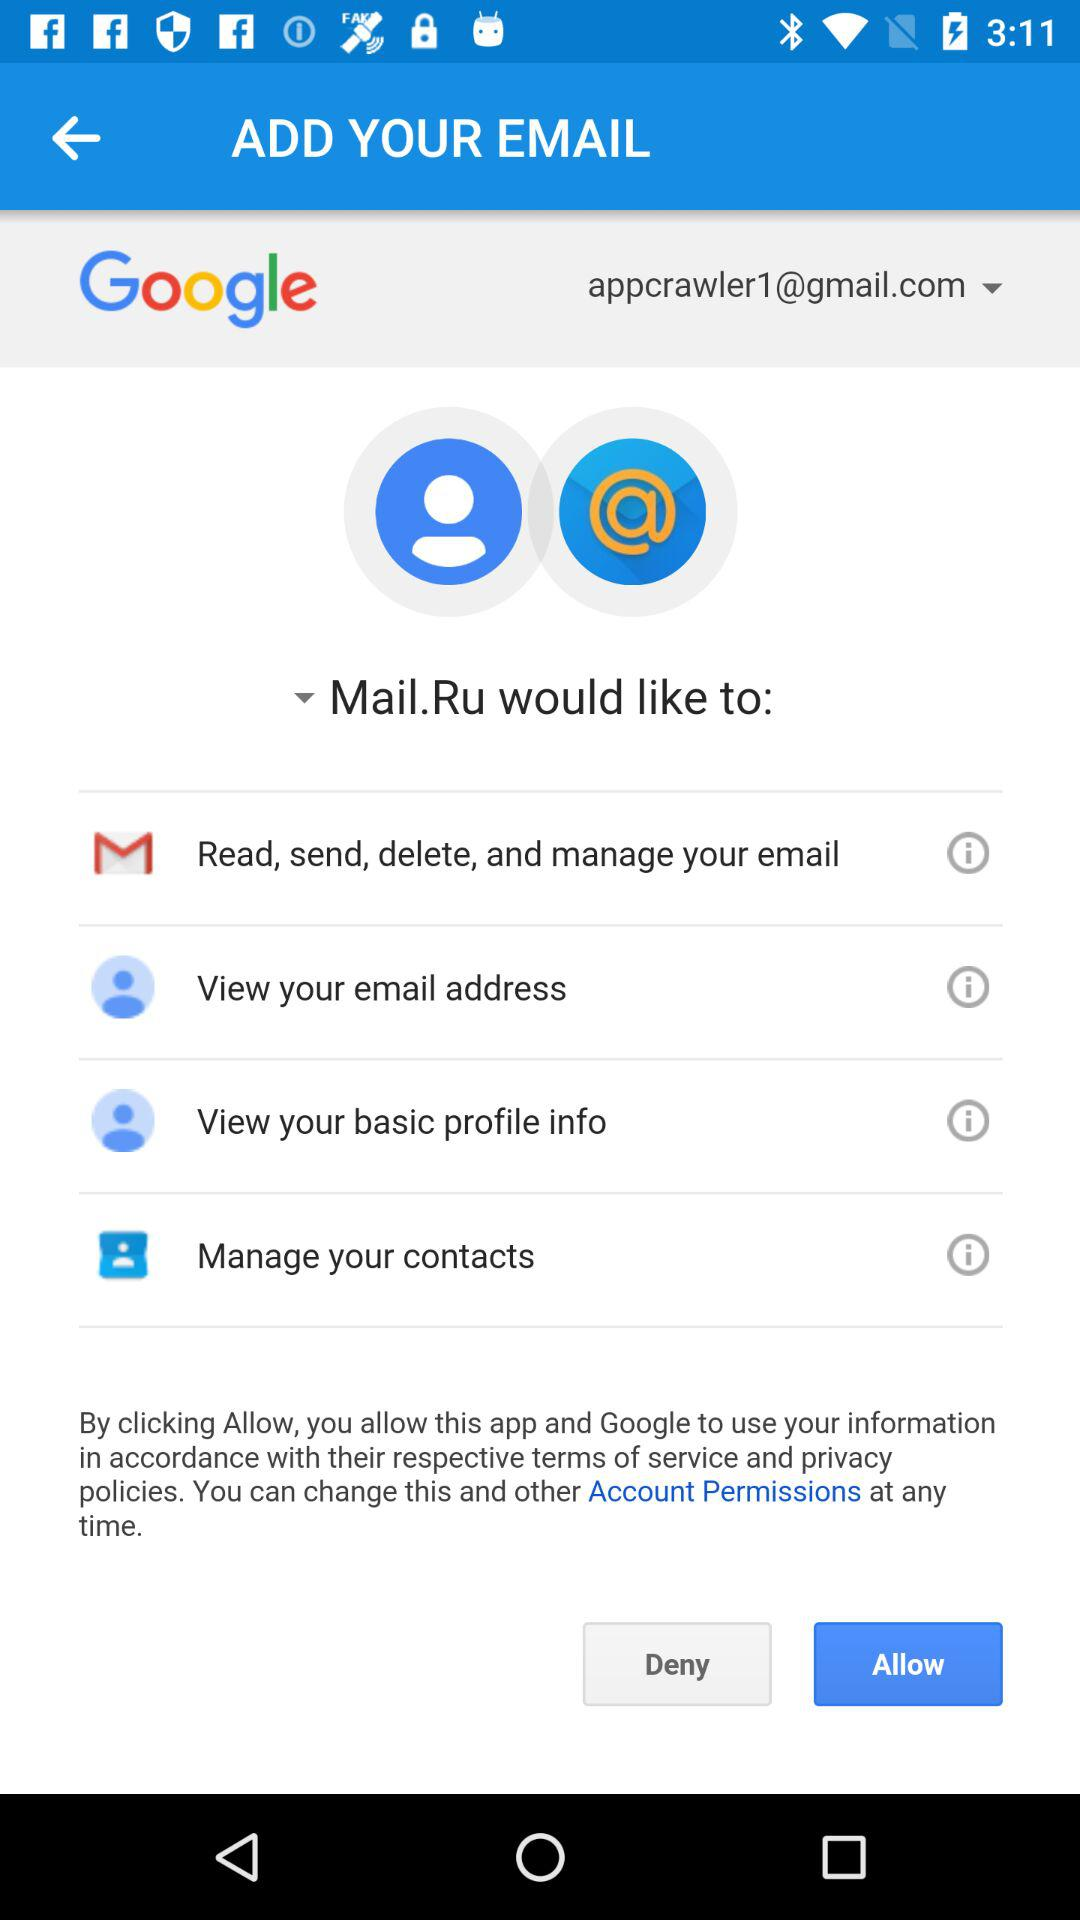Has the user agreed to the terms of service and privacy policy?
When the provided information is insufficient, respond with <no answer>. <no answer> 